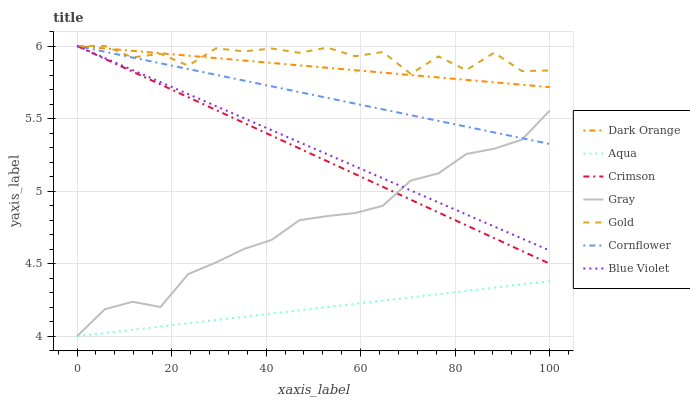Does Aqua have the minimum area under the curve?
Answer yes or no. Yes. Does Gold have the maximum area under the curve?
Answer yes or no. Yes. Does Cornflower have the minimum area under the curve?
Answer yes or no. No. Does Cornflower have the maximum area under the curve?
Answer yes or no. No. Is Aqua the smoothest?
Answer yes or no. Yes. Is Gold the roughest?
Answer yes or no. Yes. Is Cornflower the smoothest?
Answer yes or no. No. Is Cornflower the roughest?
Answer yes or no. No. Does Aqua have the lowest value?
Answer yes or no. Yes. Does Cornflower have the lowest value?
Answer yes or no. No. Does Blue Violet have the highest value?
Answer yes or no. Yes. Does Aqua have the highest value?
Answer yes or no. No. Is Gray less than Gold?
Answer yes or no. Yes. Is Crimson greater than Aqua?
Answer yes or no. Yes. Does Crimson intersect Gold?
Answer yes or no. Yes. Is Crimson less than Gold?
Answer yes or no. No. Is Crimson greater than Gold?
Answer yes or no. No. Does Gray intersect Gold?
Answer yes or no. No. 